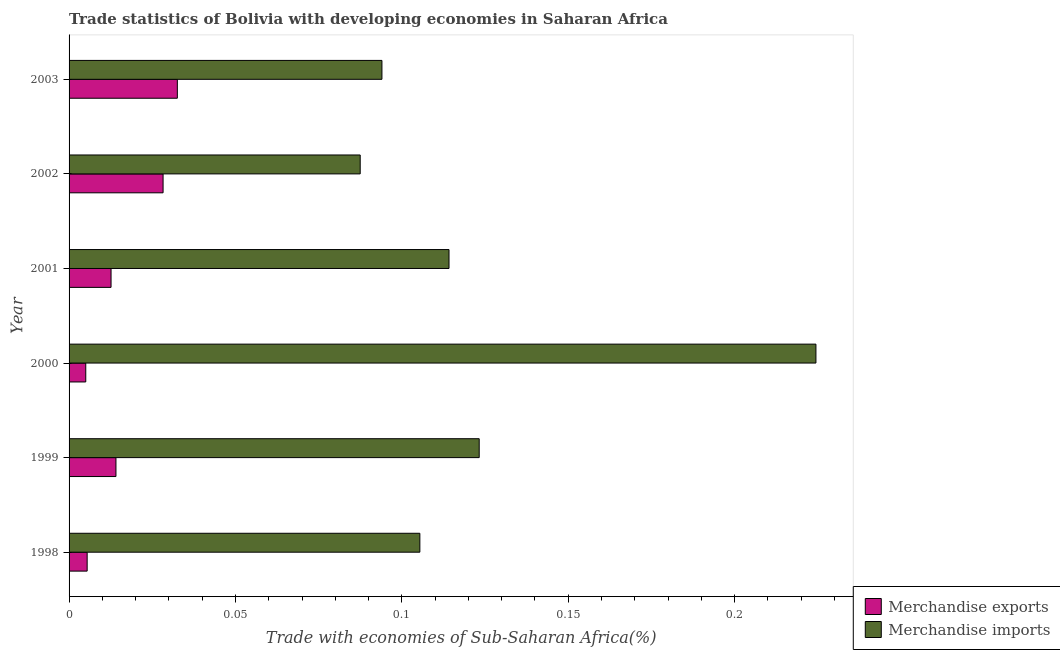How many different coloured bars are there?
Make the answer very short. 2. How many groups of bars are there?
Provide a succinct answer. 6. Are the number of bars on each tick of the Y-axis equal?
Ensure brevity in your answer.  Yes. How many bars are there on the 1st tick from the top?
Your answer should be very brief. 2. How many bars are there on the 3rd tick from the bottom?
Give a very brief answer. 2. What is the label of the 2nd group of bars from the top?
Your answer should be very brief. 2002. What is the merchandise imports in 2000?
Make the answer very short. 0.22. Across all years, what is the maximum merchandise exports?
Ensure brevity in your answer.  0.03. Across all years, what is the minimum merchandise exports?
Provide a succinct answer. 0.01. In which year was the merchandise imports minimum?
Offer a very short reply. 2002. What is the total merchandise imports in the graph?
Give a very brief answer. 0.75. What is the difference between the merchandise exports in 1999 and that in 2003?
Offer a very short reply. -0.02. What is the difference between the merchandise imports in 1998 and the merchandise exports in 2001?
Make the answer very short. 0.09. What is the average merchandise exports per year?
Offer a very short reply. 0.02. In the year 2003, what is the difference between the merchandise exports and merchandise imports?
Your answer should be compact. -0.06. What is the ratio of the merchandise exports in 2002 to that in 2003?
Your answer should be compact. 0.87. Is the merchandise imports in 2001 less than that in 2002?
Make the answer very short. No. Is the difference between the merchandise imports in 1998 and 2000 greater than the difference between the merchandise exports in 1998 and 2000?
Provide a succinct answer. No. What is the difference between the highest and the second highest merchandise exports?
Your answer should be compact. 0. What is the difference between the highest and the lowest merchandise exports?
Your answer should be compact. 0.03. In how many years, is the merchandise exports greater than the average merchandise exports taken over all years?
Give a very brief answer. 2. What does the 2nd bar from the bottom in 2000 represents?
Make the answer very short. Merchandise imports. Are the values on the major ticks of X-axis written in scientific E-notation?
Your answer should be compact. No. Does the graph contain any zero values?
Your answer should be compact. No. How many legend labels are there?
Give a very brief answer. 2. How are the legend labels stacked?
Your response must be concise. Vertical. What is the title of the graph?
Provide a short and direct response. Trade statistics of Bolivia with developing economies in Saharan Africa. What is the label or title of the X-axis?
Keep it short and to the point. Trade with economies of Sub-Saharan Africa(%). What is the label or title of the Y-axis?
Ensure brevity in your answer.  Year. What is the Trade with economies of Sub-Saharan Africa(%) of Merchandise exports in 1998?
Provide a succinct answer. 0.01. What is the Trade with economies of Sub-Saharan Africa(%) of Merchandise imports in 1998?
Give a very brief answer. 0.11. What is the Trade with economies of Sub-Saharan Africa(%) of Merchandise exports in 1999?
Make the answer very short. 0.01. What is the Trade with economies of Sub-Saharan Africa(%) in Merchandise imports in 1999?
Your answer should be compact. 0.12. What is the Trade with economies of Sub-Saharan Africa(%) of Merchandise exports in 2000?
Provide a succinct answer. 0.01. What is the Trade with economies of Sub-Saharan Africa(%) in Merchandise imports in 2000?
Provide a succinct answer. 0.22. What is the Trade with economies of Sub-Saharan Africa(%) in Merchandise exports in 2001?
Ensure brevity in your answer.  0.01. What is the Trade with economies of Sub-Saharan Africa(%) in Merchandise imports in 2001?
Your answer should be compact. 0.11. What is the Trade with economies of Sub-Saharan Africa(%) of Merchandise exports in 2002?
Offer a very short reply. 0.03. What is the Trade with economies of Sub-Saharan Africa(%) of Merchandise imports in 2002?
Offer a very short reply. 0.09. What is the Trade with economies of Sub-Saharan Africa(%) of Merchandise exports in 2003?
Your answer should be very brief. 0.03. What is the Trade with economies of Sub-Saharan Africa(%) of Merchandise imports in 2003?
Keep it short and to the point. 0.09. Across all years, what is the maximum Trade with economies of Sub-Saharan Africa(%) in Merchandise exports?
Your answer should be compact. 0.03. Across all years, what is the maximum Trade with economies of Sub-Saharan Africa(%) of Merchandise imports?
Provide a short and direct response. 0.22. Across all years, what is the minimum Trade with economies of Sub-Saharan Africa(%) in Merchandise exports?
Give a very brief answer. 0.01. Across all years, what is the minimum Trade with economies of Sub-Saharan Africa(%) in Merchandise imports?
Ensure brevity in your answer.  0.09. What is the total Trade with economies of Sub-Saharan Africa(%) in Merchandise exports in the graph?
Your answer should be compact. 0.1. What is the total Trade with economies of Sub-Saharan Africa(%) of Merchandise imports in the graph?
Keep it short and to the point. 0.75. What is the difference between the Trade with economies of Sub-Saharan Africa(%) in Merchandise exports in 1998 and that in 1999?
Offer a terse response. -0.01. What is the difference between the Trade with economies of Sub-Saharan Africa(%) of Merchandise imports in 1998 and that in 1999?
Offer a terse response. -0.02. What is the difference between the Trade with economies of Sub-Saharan Africa(%) in Merchandise imports in 1998 and that in 2000?
Provide a succinct answer. -0.12. What is the difference between the Trade with economies of Sub-Saharan Africa(%) in Merchandise exports in 1998 and that in 2001?
Provide a short and direct response. -0.01. What is the difference between the Trade with economies of Sub-Saharan Africa(%) of Merchandise imports in 1998 and that in 2001?
Provide a succinct answer. -0.01. What is the difference between the Trade with economies of Sub-Saharan Africa(%) of Merchandise exports in 1998 and that in 2002?
Your answer should be very brief. -0.02. What is the difference between the Trade with economies of Sub-Saharan Africa(%) of Merchandise imports in 1998 and that in 2002?
Offer a very short reply. 0.02. What is the difference between the Trade with economies of Sub-Saharan Africa(%) of Merchandise exports in 1998 and that in 2003?
Ensure brevity in your answer.  -0.03. What is the difference between the Trade with economies of Sub-Saharan Africa(%) in Merchandise imports in 1998 and that in 2003?
Ensure brevity in your answer.  0.01. What is the difference between the Trade with economies of Sub-Saharan Africa(%) in Merchandise exports in 1999 and that in 2000?
Your answer should be very brief. 0.01. What is the difference between the Trade with economies of Sub-Saharan Africa(%) of Merchandise imports in 1999 and that in 2000?
Make the answer very short. -0.1. What is the difference between the Trade with economies of Sub-Saharan Africa(%) in Merchandise exports in 1999 and that in 2001?
Your answer should be very brief. 0. What is the difference between the Trade with economies of Sub-Saharan Africa(%) of Merchandise imports in 1999 and that in 2001?
Your response must be concise. 0.01. What is the difference between the Trade with economies of Sub-Saharan Africa(%) of Merchandise exports in 1999 and that in 2002?
Offer a terse response. -0.01. What is the difference between the Trade with economies of Sub-Saharan Africa(%) of Merchandise imports in 1999 and that in 2002?
Keep it short and to the point. 0.04. What is the difference between the Trade with economies of Sub-Saharan Africa(%) of Merchandise exports in 1999 and that in 2003?
Keep it short and to the point. -0.02. What is the difference between the Trade with economies of Sub-Saharan Africa(%) of Merchandise imports in 1999 and that in 2003?
Your answer should be compact. 0.03. What is the difference between the Trade with economies of Sub-Saharan Africa(%) in Merchandise exports in 2000 and that in 2001?
Your answer should be very brief. -0.01. What is the difference between the Trade with economies of Sub-Saharan Africa(%) in Merchandise imports in 2000 and that in 2001?
Your response must be concise. 0.11. What is the difference between the Trade with economies of Sub-Saharan Africa(%) in Merchandise exports in 2000 and that in 2002?
Offer a very short reply. -0.02. What is the difference between the Trade with economies of Sub-Saharan Africa(%) of Merchandise imports in 2000 and that in 2002?
Give a very brief answer. 0.14. What is the difference between the Trade with economies of Sub-Saharan Africa(%) in Merchandise exports in 2000 and that in 2003?
Give a very brief answer. -0.03. What is the difference between the Trade with economies of Sub-Saharan Africa(%) in Merchandise imports in 2000 and that in 2003?
Ensure brevity in your answer.  0.13. What is the difference between the Trade with economies of Sub-Saharan Africa(%) in Merchandise exports in 2001 and that in 2002?
Offer a terse response. -0.02. What is the difference between the Trade with economies of Sub-Saharan Africa(%) of Merchandise imports in 2001 and that in 2002?
Your answer should be compact. 0.03. What is the difference between the Trade with economies of Sub-Saharan Africa(%) in Merchandise exports in 2001 and that in 2003?
Ensure brevity in your answer.  -0.02. What is the difference between the Trade with economies of Sub-Saharan Africa(%) in Merchandise imports in 2001 and that in 2003?
Ensure brevity in your answer.  0.02. What is the difference between the Trade with economies of Sub-Saharan Africa(%) in Merchandise exports in 2002 and that in 2003?
Your answer should be very brief. -0. What is the difference between the Trade with economies of Sub-Saharan Africa(%) of Merchandise imports in 2002 and that in 2003?
Provide a succinct answer. -0.01. What is the difference between the Trade with economies of Sub-Saharan Africa(%) of Merchandise exports in 1998 and the Trade with economies of Sub-Saharan Africa(%) of Merchandise imports in 1999?
Your response must be concise. -0.12. What is the difference between the Trade with economies of Sub-Saharan Africa(%) in Merchandise exports in 1998 and the Trade with economies of Sub-Saharan Africa(%) in Merchandise imports in 2000?
Offer a terse response. -0.22. What is the difference between the Trade with economies of Sub-Saharan Africa(%) of Merchandise exports in 1998 and the Trade with economies of Sub-Saharan Africa(%) of Merchandise imports in 2001?
Ensure brevity in your answer.  -0.11. What is the difference between the Trade with economies of Sub-Saharan Africa(%) in Merchandise exports in 1998 and the Trade with economies of Sub-Saharan Africa(%) in Merchandise imports in 2002?
Keep it short and to the point. -0.08. What is the difference between the Trade with economies of Sub-Saharan Africa(%) in Merchandise exports in 1998 and the Trade with economies of Sub-Saharan Africa(%) in Merchandise imports in 2003?
Ensure brevity in your answer.  -0.09. What is the difference between the Trade with economies of Sub-Saharan Africa(%) of Merchandise exports in 1999 and the Trade with economies of Sub-Saharan Africa(%) of Merchandise imports in 2000?
Keep it short and to the point. -0.21. What is the difference between the Trade with economies of Sub-Saharan Africa(%) of Merchandise exports in 1999 and the Trade with economies of Sub-Saharan Africa(%) of Merchandise imports in 2001?
Ensure brevity in your answer.  -0.1. What is the difference between the Trade with economies of Sub-Saharan Africa(%) in Merchandise exports in 1999 and the Trade with economies of Sub-Saharan Africa(%) in Merchandise imports in 2002?
Your response must be concise. -0.07. What is the difference between the Trade with economies of Sub-Saharan Africa(%) in Merchandise exports in 1999 and the Trade with economies of Sub-Saharan Africa(%) in Merchandise imports in 2003?
Offer a terse response. -0.08. What is the difference between the Trade with economies of Sub-Saharan Africa(%) in Merchandise exports in 2000 and the Trade with economies of Sub-Saharan Africa(%) in Merchandise imports in 2001?
Keep it short and to the point. -0.11. What is the difference between the Trade with economies of Sub-Saharan Africa(%) of Merchandise exports in 2000 and the Trade with economies of Sub-Saharan Africa(%) of Merchandise imports in 2002?
Give a very brief answer. -0.08. What is the difference between the Trade with economies of Sub-Saharan Africa(%) of Merchandise exports in 2000 and the Trade with economies of Sub-Saharan Africa(%) of Merchandise imports in 2003?
Your answer should be compact. -0.09. What is the difference between the Trade with economies of Sub-Saharan Africa(%) of Merchandise exports in 2001 and the Trade with economies of Sub-Saharan Africa(%) of Merchandise imports in 2002?
Give a very brief answer. -0.07. What is the difference between the Trade with economies of Sub-Saharan Africa(%) in Merchandise exports in 2001 and the Trade with economies of Sub-Saharan Africa(%) in Merchandise imports in 2003?
Your response must be concise. -0.08. What is the difference between the Trade with economies of Sub-Saharan Africa(%) of Merchandise exports in 2002 and the Trade with economies of Sub-Saharan Africa(%) of Merchandise imports in 2003?
Your response must be concise. -0.07. What is the average Trade with economies of Sub-Saharan Africa(%) of Merchandise exports per year?
Provide a succinct answer. 0.02. What is the average Trade with economies of Sub-Saharan Africa(%) in Merchandise imports per year?
Ensure brevity in your answer.  0.12. In the year 1999, what is the difference between the Trade with economies of Sub-Saharan Africa(%) of Merchandise exports and Trade with economies of Sub-Saharan Africa(%) of Merchandise imports?
Give a very brief answer. -0.11. In the year 2000, what is the difference between the Trade with economies of Sub-Saharan Africa(%) of Merchandise exports and Trade with economies of Sub-Saharan Africa(%) of Merchandise imports?
Your answer should be very brief. -0.22. In the year 2001, what is the difference between the Trade with economies of Sub-Saharan Africa(%) of Merchandise exports and Trade with economies of Sub-Saharan Africa(%) of Merchandise imports?
Provide a succinct answer. -0.1. In the year 2002, what is the difference between the Trade with economies of Sub-Saharan Africa(%) of Merchandise exports and Trade with economies of Sub-Saharan Africa(%) of Merchandise imports?
Make the answer very short. -0.06. In the year 2003, what is the difference between the Trade with economies of Sub-Saharan Africa(%) in Merchandise exports and Trade with economies of Sub-Saharan Africa(%) in Merchandise imports?
Your answer should be very brief. -0.06. What is the ratio of the Trade with economies of Sub-Saharan Africa(%) in Merchandise exports in 1998 to that in 1999?
Provide a short and direct response. 0.39. What is the ratio of the Trade with economies of Sub-Saharan Africa(%) of Merchandise imports in 1998 to that in 1999?
Keep it short and to the point. 0.86. What is the ratio of the Trade with economies of Sub-Saharan Africa(%) of Merchandise exports in 1998 to that in 2000?
Give a very brief answer. 1.08. What is the ratio of the Trade with economies of Sub-Saharan Africa(%) in Merchandise imports in 1998 to that in 2000?
Give a very brief answer. 0.47. What is the ratio of the Trade with economies of Sub-Saharan Africa(%) in Merchandise exports in 1998 to that in 2001?
Offer a very short reply. 0.43. What is the ratio of the Trade with economies of Sub-Saharan Africa(%) in Merchandise imports in 1998 to that in 2001?
Offer a very short reply. 0.92. What is the ratio of the Trade with economies of Sub-Saharan Africa(%) in Merchandise exports in 1998 to that in 2002?
Your answer should be compact. 0.19. What is the ratio of the Trade with economies of Sub-Saharan Africa(%) in Merchandise imports in 1998 to that in 2002?
Offer a terse response. 1.2. What is the ratio of the Trade with economies of Sub-Saharan Africa(%) of Merchandise exports in 1998 to that in 2003?
Ensure brevity in your answer.  0.17. What is the ratio of the Trade with economies of Sub-Saharan Africa(%) in Merchandise imports in 1998 to that in 2003?
Provide a short and direct response. 1.12. What is the ratio of the Trade with economies of Sub-Saharan Africa(%) in Merchandise exports in 1999 to that in 2000?
Offer a very short reply. 2.81. What is the ratio of the Trade with economies of Sub-Saharan Africa(%) of Merchandise imports in 1999 to that in 2000?
Your response must be concise. 0.55. What is the ratio of the Trade with economies of Sub-Saharan Africa(%) in Merchandise exports in 1999 to that in 2001?
Your answer should be very brief. 1.12. What is the ratio of the Trade with economies of Sub-Saharan Africa(%) of Merchandise imports in 1999 to that in 2001?
Your answer should be very brief. 1.08. What is the ratio of the Trade with economies of Sub-Saharan Africa(%) of Merchandise exports in 1999 to that in 2002?
Your answer should be very brief. 0.5. What is the ratio of the Trade with economies of Sub-Saharan Africa(%) of Merchandise imports in 1999 to that in 2002?
Ensure brevity in your answer.  1.41. What is the ratio of the Trade with economies of Sub-Saharan Africa(%) of Merchandise exports in 1999 to that in 2003?
Your answer should be compact. 0.43. What is the ratio of the Trade with economies of Sub-Saharan Africa(%) of Merchandise imports in 1999 to that in 2003?
Ensure brevity in your answer.  1.31. What is the ratio of the Trade with economies of Sub-Saharan Africa(%) of Merchandise exports in 2000 to that in 2001?
Make the answer very short. 0.4. What is the ratio of the Trade with economies of Sub-Saharan Africa(%) in Merchandise imports in 2000 to that in 2001?
Make the answer very short. 1.97. What is the ratio of the Trade with economies of Sub-Saharan Africa(%) in Merchandise exports in 2000 to that in 2002?
Keep it short and to the point. 0.18. What is the ratio of the Trade with economies of Sub-Saharan Africa(%) of Merchandise imports in 2000 to that in 2002?
Offer a very short reply. 2.57. What is the ratio of the Trade with economies of Sub-Saharan Africa(%) of Merchandise exports in 2000 to that in 2003?
Your answer should be compact. 0.15. What is the ratio of the Trade with economies of Sub-Saharan Africa(%) of Merchandise imports in 2000 to that in 2003?
Give a very brief answer. 2.39. What is the ratio of the Trade with economies of Sub-Saharan Africa(%) in Merchandise exports in 2001 to that in 2002?
Give a very brief answer. 0.45. What is the ratio of the Trade with economies of Sub-Saharan Africa(%) of Merchandise imports in 2001 to that in 2002?
Ensure brevity in your answer.  1.31. What is the ratio of the Trade with economies of Sub-Saharan Africa(%) of Merchandise exports in 2001 to that in 2003?
Make the answer very short. 0.39. What is the ratio of the Trade with economies of Sub-Saharan Africa(%) of Merchandise imports in 2001 to that in 2003?
Your answer should be compact. 1.21. What is the ratio of the Trade with economies of Sub-Saharan Africa(%) of Merchandise exports in 2002 to that in 2003?
Keep it short and to the point. 0.87. What is the ratio of the Trade with economies of Sub-Saharan Africa(%) of Merchandise imports in 2002 to that in 2003?
Keep it short and to the point. 0.93. What is the difference between the highest and the second highest Trade with economies of Sub-Saharan Africa(%) of Merchandise exports?
Your answer should be very brief. 0. What is the difference between the highest and the second highest Trade with economies of Sub-Saharan Africa(%) of Merchandise imports?
Make the answer very short. 0.1. What is the difference between the highest and the lowest Trade with economies of Sub-Saharan Africa(%) in Merchandise exports?
Provide a short and direct response. 0.03. What is the difference between the highest and the lowest Trade with economies of Sub-Saharan Africa(%) of Merchandise imports?
Keep it short and to the point. 0.14. 